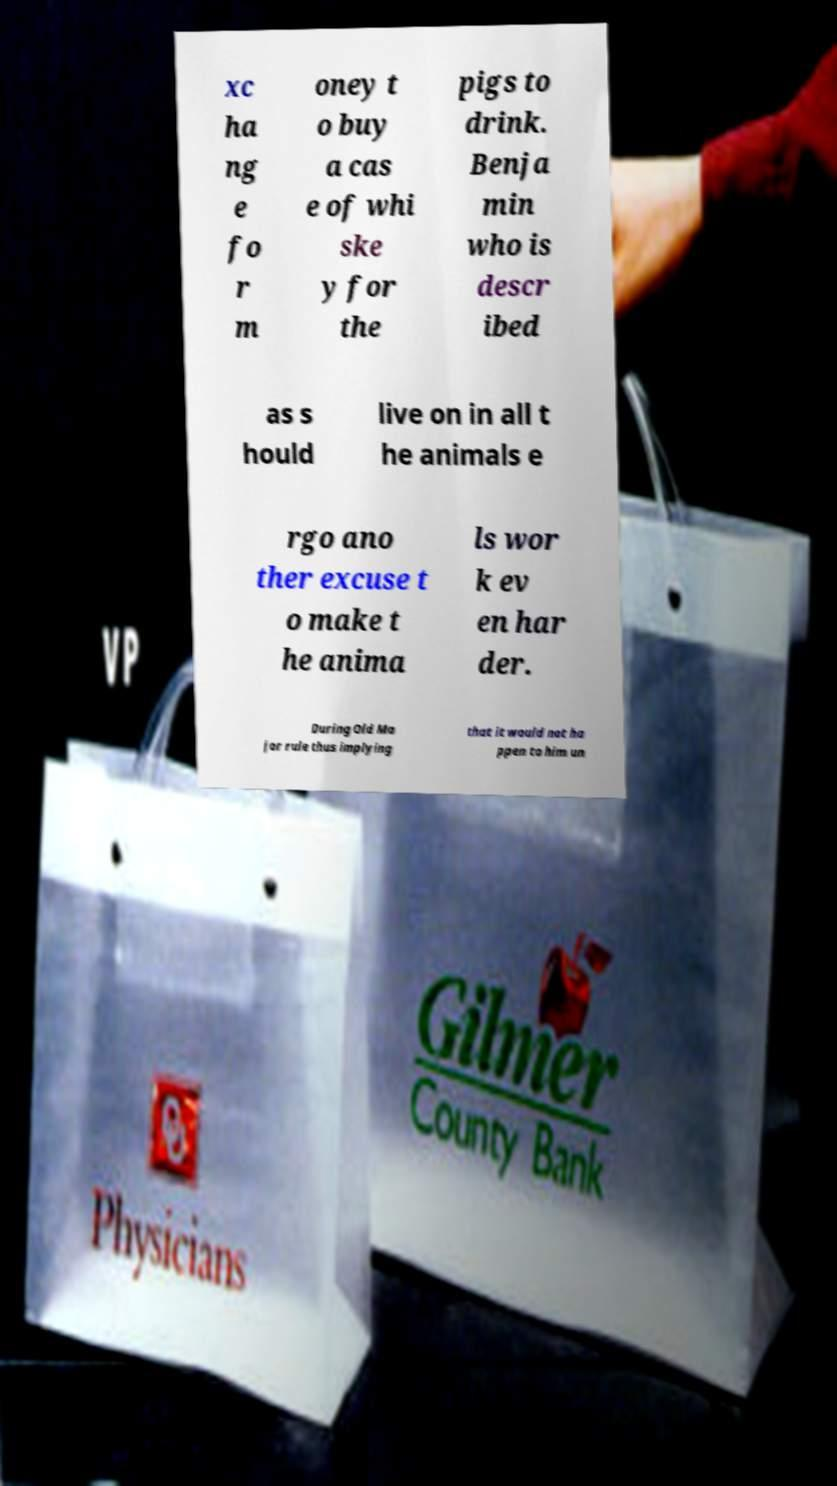Please read and relay the text visible in this image. What does it say? xc ha ng e fo r m oney t o buy a cas e of whi ske y for the pigs to drink. Benja min who is descr ibed as s hould live on in all t he animals e rgo ano ther excuse t o make t he anima ls wor k ev en har der. During Old Ma jor rule thus implying that it would not ha ppen to him un 